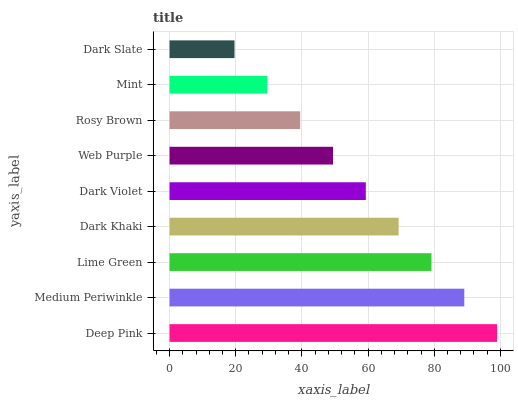Is Dark Slate the minimum?
Answer yes or no. Yes. Is Deep Pink the maximum?
Answer yes or no. Yes. Is Medium Periwinkle the minimum?
Answer yes or no. No. Is Medium Periwinkle the maximum?
Answer yes or no. No. Is Deep Pink greater than Medium Periwinkle?
Answer yes or no. Yes. Is Medium Periwinkle less than Deep Pink?
Answer yes or no. Yes. Is Medium Periwinkle greater than Deep Pink?
Answer yes or no. No. Is Deep Pink less than Medium Periwinkle?
Answer yes or no. No. Is Dark Violet the high median?
Answer yes or no. Yes. Is Dark Violet the low median?
Answer yes or no. Yes. Is Rosy Brown the high median?
Answer yes or no. No. Is Rosy Brown the low median?
Answer yes or no. No. 